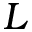Convert formula to latex. <formula><loc_0><loc_0><loc_500><loc_500>L</formula> 